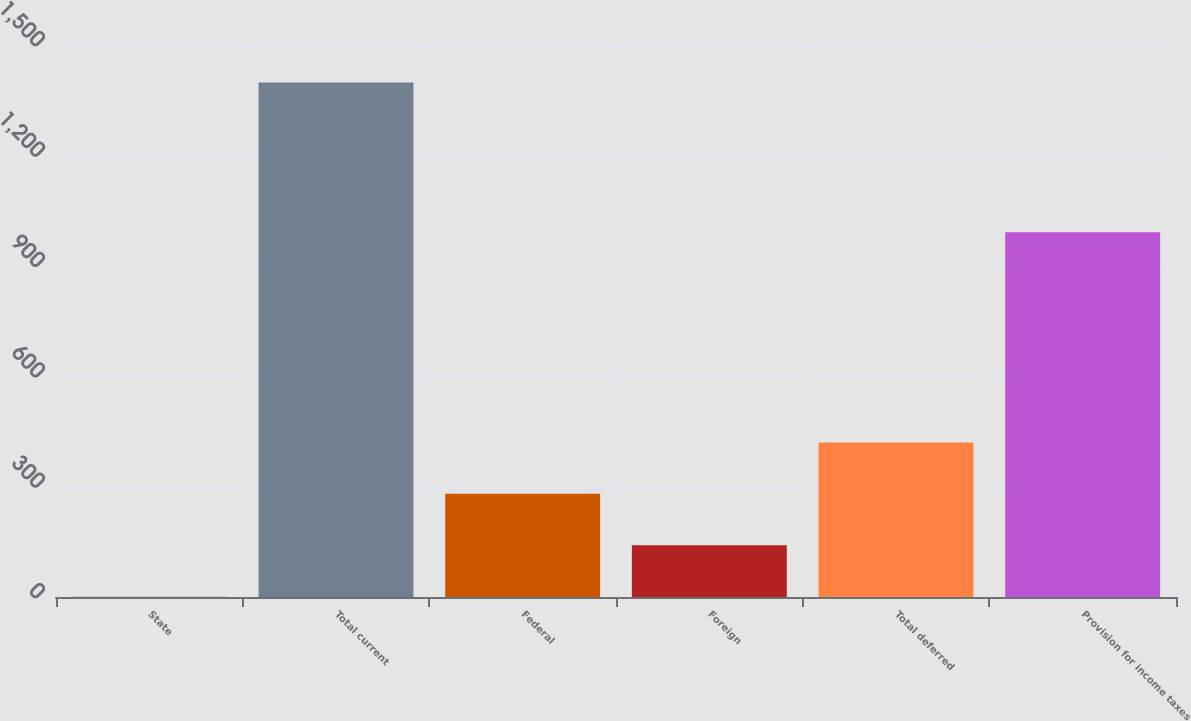Convert chart to OTSL. <chart><loc_0><loc_0><loc_500><loc_500><bar_chart><fcel>State<fcel>Total current<fcel>Federal<fcel>Foreign<fcel>Total deferred<fcel>Provision for income taxes<nl><fcel>1<fcel>1398<fcel>280.4<fcel>140.7<fcel>420.1<fcel>991<nl></chart> 